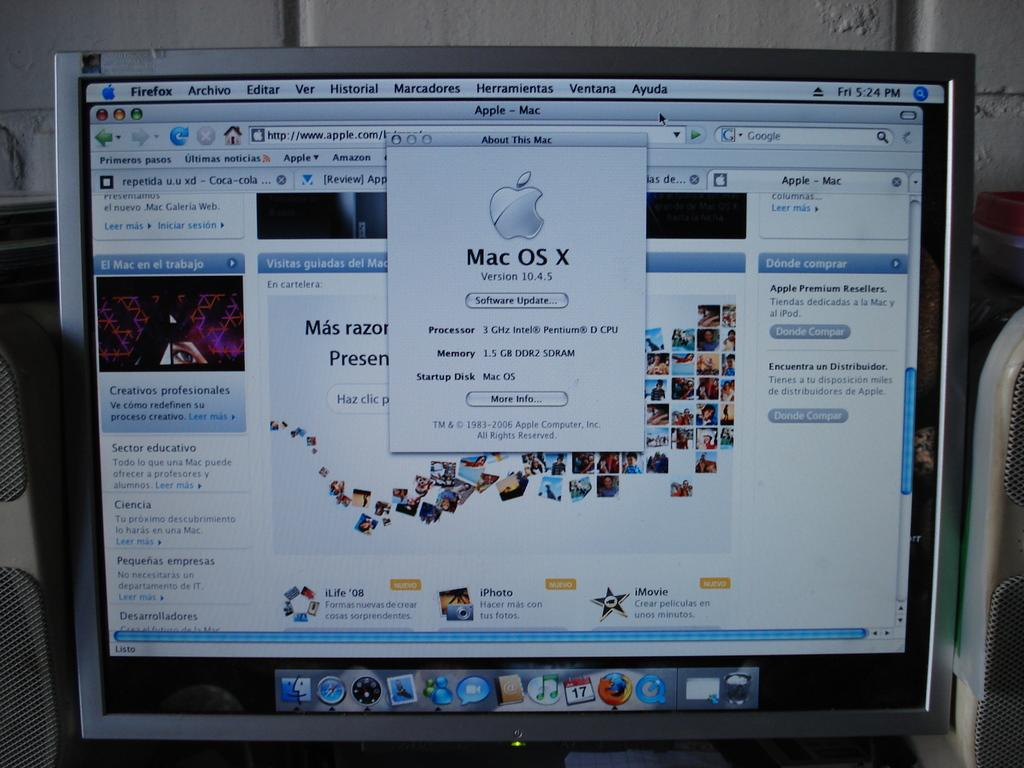<image>
Relay a brief, clear account of the picture shown. Mac computer showing a Apple Mac Software Update screen. 